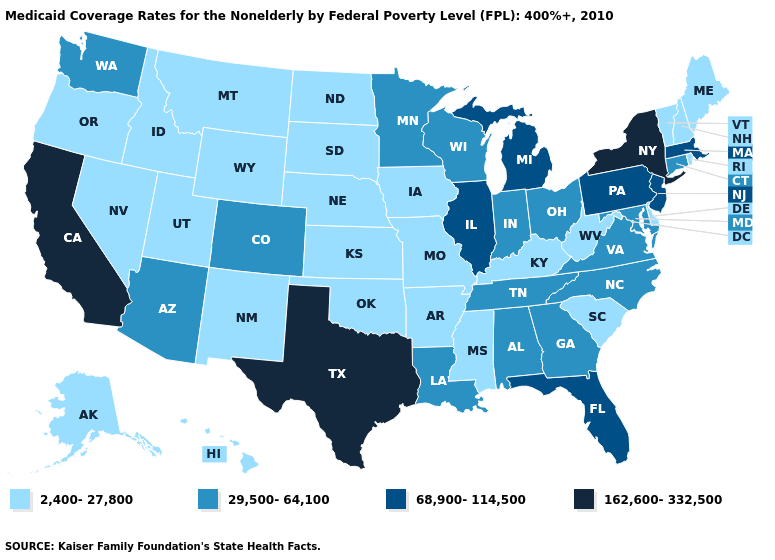What is the value of Oklahoma?
Be succinct. 2,400-27,800. Among the states that border Mississippi , does Arkansas have the highest value?
Be succinct. No. What is the lowest value in the USA?
Keep it brief. 2,400-27,800. What is the value of New York?
Be succinct. 162,600-332,500. Name the states that have a value in the range 2,400-27,800?
Quick response, please. Alaska, Arkansas, Delaware, Hawaii, Idaho, Iowa, Kansas, Kentucky, Maine, Mississippi, Missouri, Montana, Nebraska, Nevada, New Hampshire, New Mexico, North Dakota, Oklahoma, Oregon, Rhode Island, South Carolina, South Dakota, Utah, Vermont, West Virginia, Wyoming. Among the states that border Delaware , which have the lowest value?
Answer briefly. Maryland. Does the map have missing data?
Quick response, please. No. What is the value of Hawaii?
Write a very short answer. 2,400-27,800. Does Michigan have the lowest value in the USA?
Keep it brief. No. Name the states that have a value in the range 68,900-114,500?
Short answer required. Florida, Illinois, Massachusetts, Michigan, New Jersey, Pennsylvania. Does Wyoming have the highest value in the USA?
Be succinct. No. Which states have the lowest value in the West?
Answer briefly. Alaska, Hawaii, Idaho, Montana, Nevada, New Mexico, Oregon, Utah, Wyoming. Does North Dakota have the lowest value in the MidWest?
Short answer required. Yes. Does Virginia have the highest value in the USA?
Short answer required. No. What is the value of Vermont?
Be succinct. 2,400-27,800. 